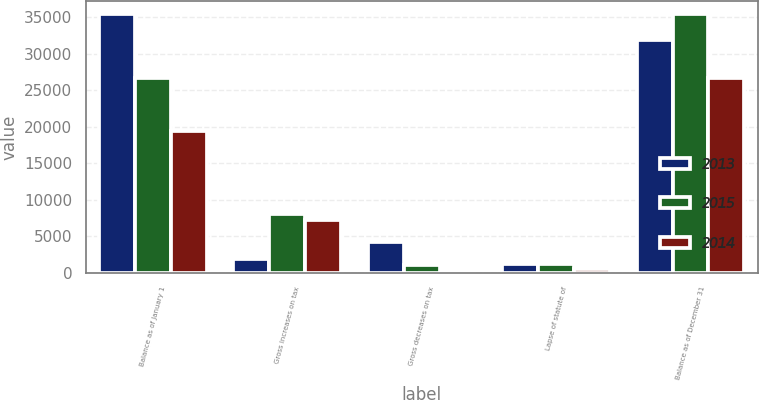Convert chart. <chart><loc_0><loc_0><loc_500><loc_500><stacked_bar_chart><ecel><fcel>Balance as of January 1<fcel>Gross increases on tax<fcel>Gross decreases on tax<fcel>Lapse of statute of<fcel>Balance as of December 31<nl><fcel>2013<fcel>35429<fcel>1891<fcel>4245<fcel>1242<fcel>31903<nl><fcel>2015<fcel>26745<fcel>8113<fcel>1053<fcel>1204<fcel>35429<nl><fcel>2014<fcel>19493<fcel>7270<fcel>18<fcel>549<fcel>26745<nl></chart> 